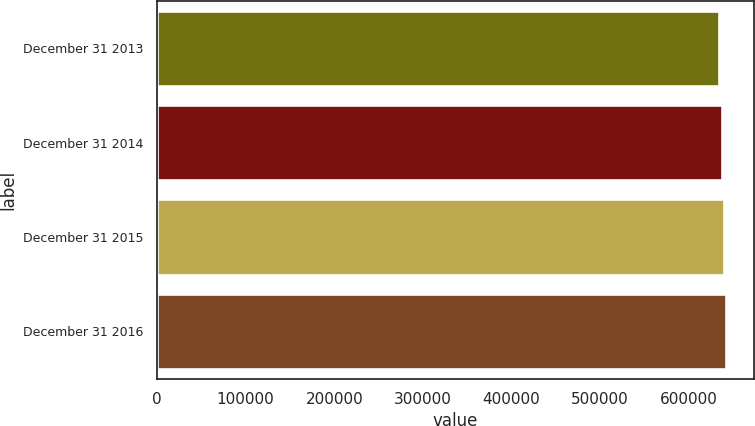Convert chart. <chart><loc_0><loc_0><loc_500><loc_500><bar_chart><fcel>December 31 2013<fcel>December 31 2014<fcel>December 31 2015<fcel>December 31 2016<nl><fcel>634286<fcel>637032<fcel>639336<fcel>641594<nl></chart> 